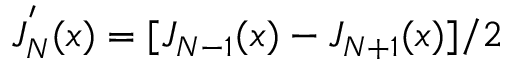Convert formula to latex. <formula><loc_0><loc_0><loc_500><loc_500>J _ { N } ^ { ^ { \prime } } ( x ) = [ J _ { N - 1 } ( x ) - J _ { N + 1 } ( x ) ] / 2</formula> 